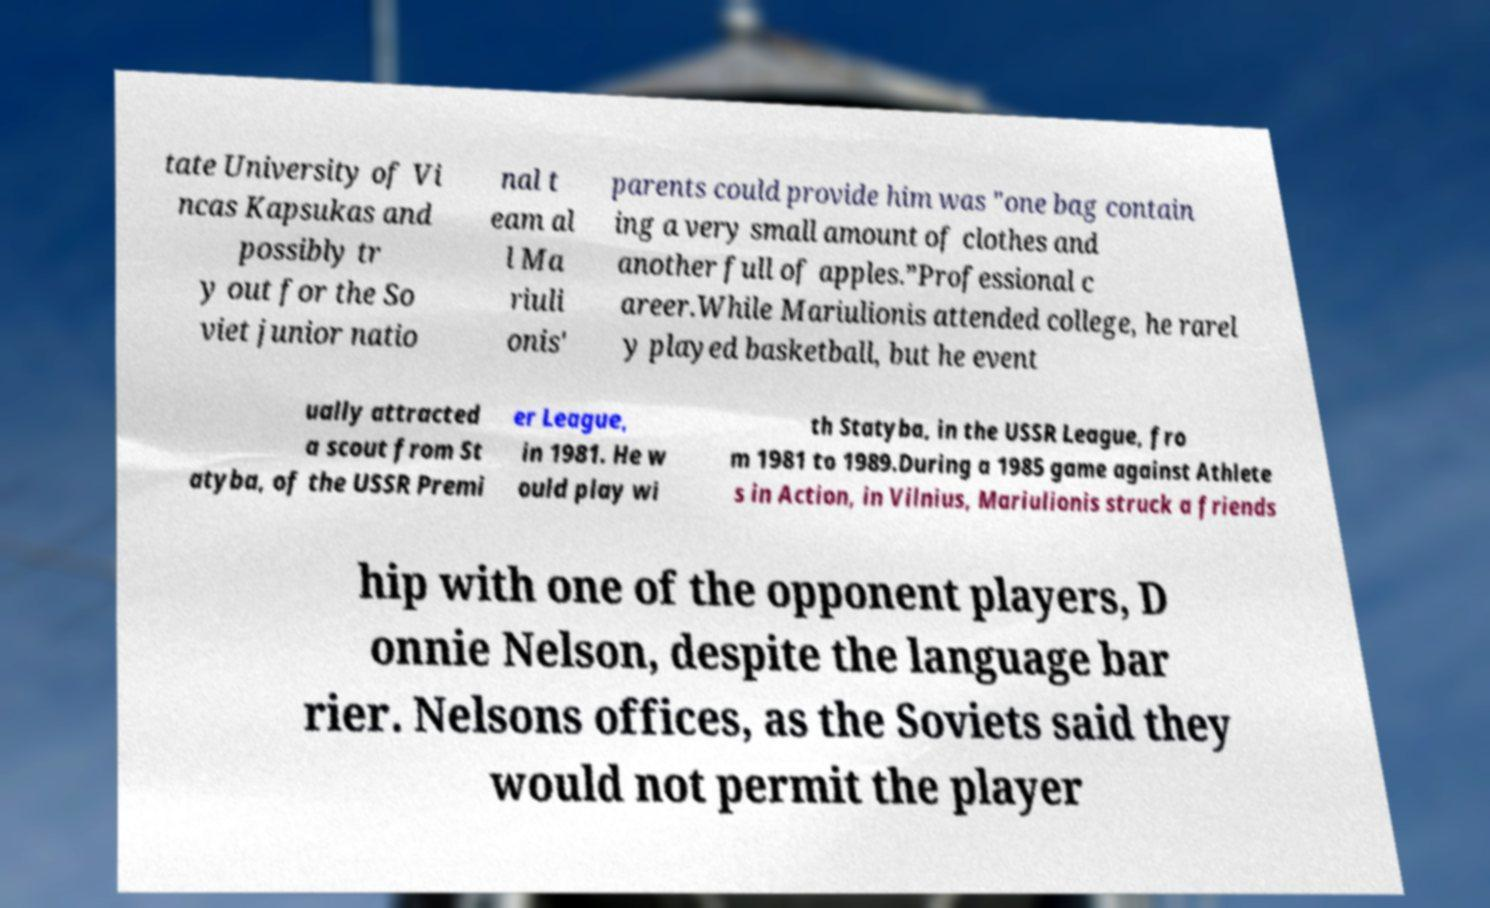There's text embedded in this image that I need extracted. Can you transcribe it verbatim? tate University of Vi ncas Kapsukas and possibly tr y out for the So viet junior natio nal t eam al l Ma riuli onis' parents could provide him was "one bag contain ing a very small amount of clothes and another full of apples.”Professional c areer.While Mariulionis attended college, he rarel y played basketball, but he event ually attracted a scout from St atyba, of the USSR Premi er League, in 1981. He w ould play wi th Statyba, in the USSR League, fro m 1981 to 1989.During a 1985 game against Athlete s in Action, in Vilnius, Mariulionis struck a friends hip with one of the opponent players, D onnie Nelson, despite the language bar rier. Nelsons offices, as the Soviets said they would not permit the player 